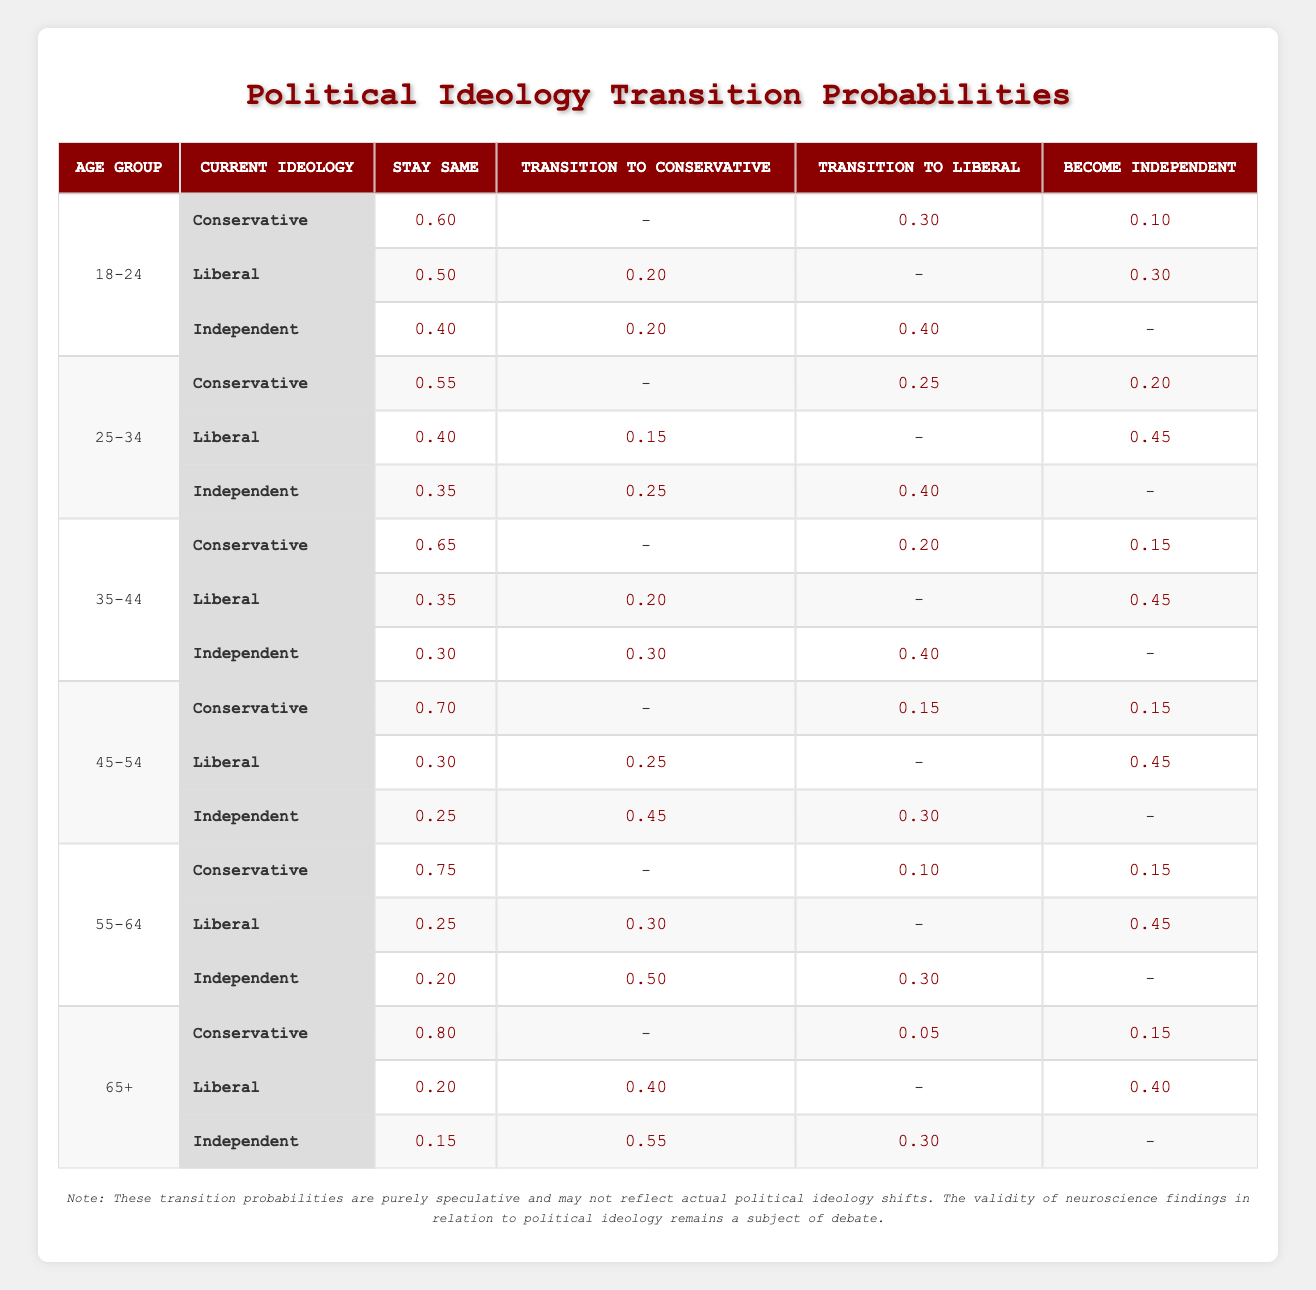What is the probability of a Liberal voter staying Liberal at age 25-34? According to the table, the probability for Liberal voters in the age group 25-34 to stay Liberal is 0.40.
Answer: 0.40 What is the probability of an Independent voter transitioning to Conservative at age 35-44? From the table, we can see that the transition probability for Independent voters to become Conservative at age 35-44 is 0.30.
Answer: 0.30 Is it true that Liberal voters tend to transition to Independent more than Conservative in the age group 55-64? For Liberal voters in the age group 55-64, the probability of transitioning to Independent is 0.45, while transitioning to Conservative is 0.30. Since 0.45 > 0.30, the statement is true.
Answer: True What is the average probability of staying the same for Conservative voters across all age groups? To find the average, we sum the probabilities of staying Conservative across each age group: 0.60 + 0.55 + 0.65 + 0.70 + 0.75 + 0.80 = 3.15. There are 6 age groups, so the average is 3.15 / 6 = 0.525.
Answer: 0.525 At what age group is the probability of Conservative voters transitioning to Liberal the lowest? By reviewing the transition probabilities to Liberal for Conservative voters, we can see that it is the lowest at the age group 65+, where the probability is 0.05.
Answer: 65+ What is the total probability of voters transitioning to Independent at age 45-54? For age group 45-54, we look at all three ideologies: Conservative (0.15), Liberal (0.45), and Independent (0.25). Now we sum these probabilities: 0.15 + 0.45 + 0.25 = 0.85.
Answer: 0.85 What is the difference in the probability of Conservative voters staying Conservative between the age groups 55-64 and 35-44? In age group 55-64, the probability of staying Conservative is 0.75, and in 35-44 it is 0.65. The difference is 0.75 - 0.65 = 0.10.
Answer: 0.10 What is the probability of a 65+ Liberal voter transitioning to Conservative? The table indicates that for a Liberal voter aged 65+, the probability of transitioning to Conservative is 0.40.
Answer: 0.40 Is it true that Independent voters are more likely to stay Independent than transition to any other ideology at age 25-34? For Independent voters aged 25-34, the probability of staying Independent is 0.35, while transitioning probabilities to Conservative and Liberal are 0.25 and 0.40 respectively. Since 0.35 is less than the sum (0.25 + 0.40 = 0.65), the statement is false.
Answer: False 